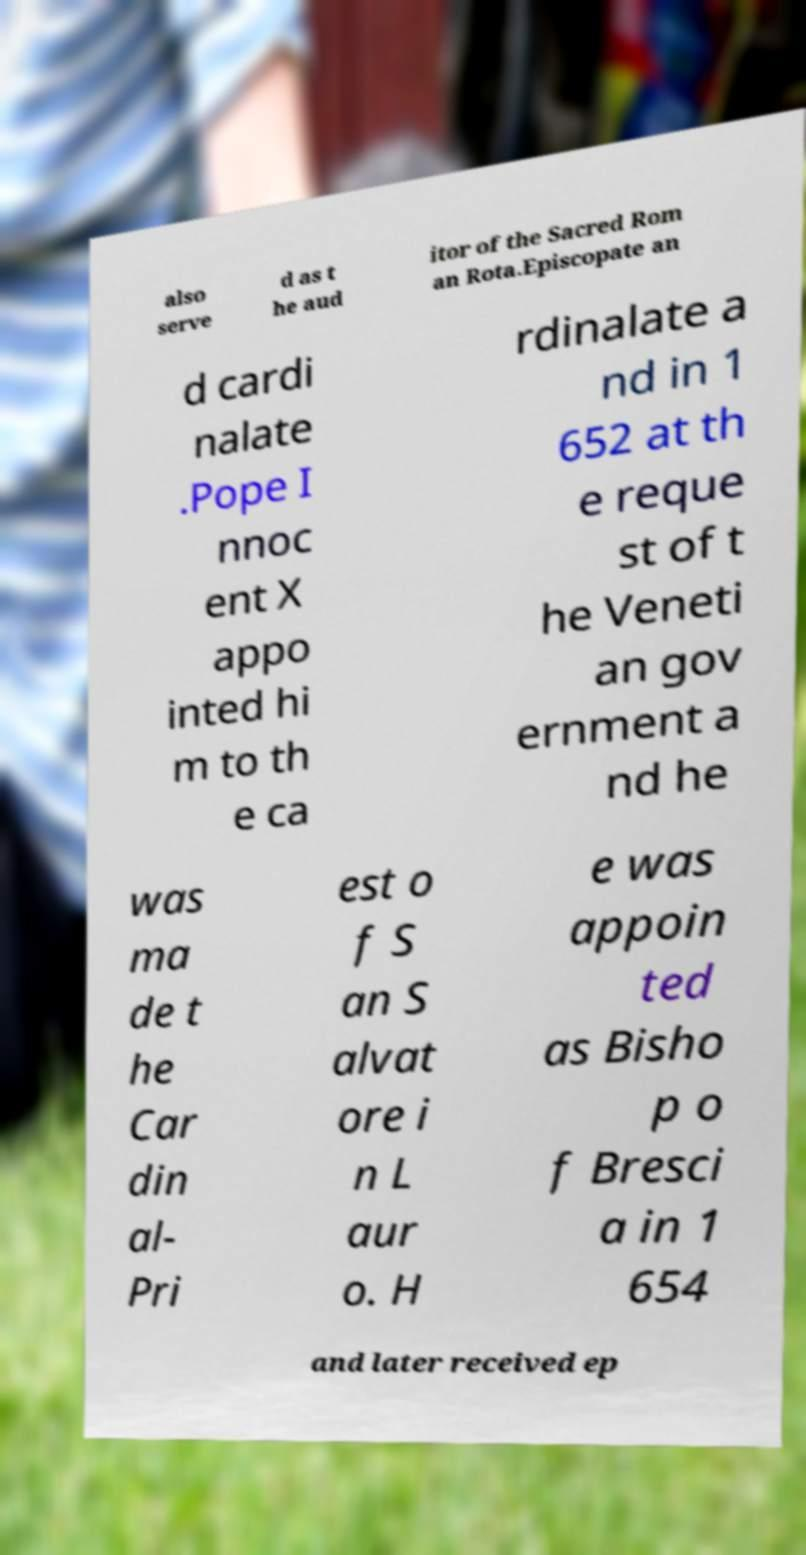For documentation purposes, I need the text within this image transcribed. Could you provide that? also serve d as t he aud itor of the Sacred Rom an Rota.Episcopate an d cardi nalate .Pope I nnoc ent X appo inted hi m to th e ca rdinalate a nd in 1 652 at th e reque st of t he Veneti an gov ernment a nd he was ma de t he Car din al- Pri est o f S an S alvat ore i n L aur o. H e was appoin ted as Bisho p o f Bresci a in 1 654 and later received ep 